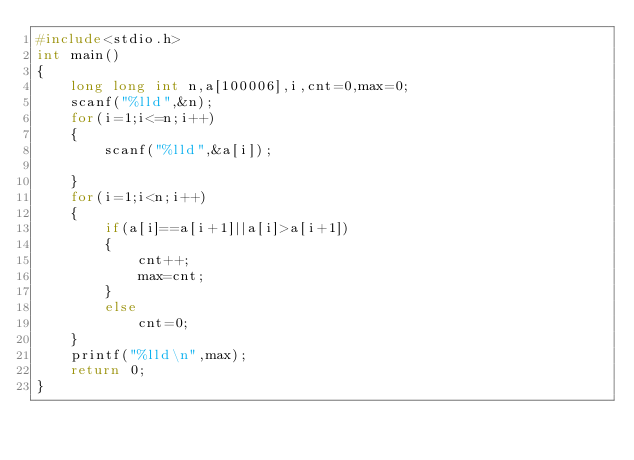<code> <loc_0><loc_0><loc_500><loc_500><_C_>#include<stdio.h>
int main()
{
    long long int n,a[100006],i,cnt=0,max=0;
    scanf("%lld",&n);
    for(i=1;i<=n;i++)
    {
        scanf("%lld",&a[i]);

    }
    for(i=1;i<n;i++)
    {
        if(a[i]==a[i+1]||a[i]>a[i+1])
        {
            cnt++;
            max=cnt;
        }
        else
            cnt=0;
    }
    printf("%lld\n",max);
    return 0;
}
</code> 